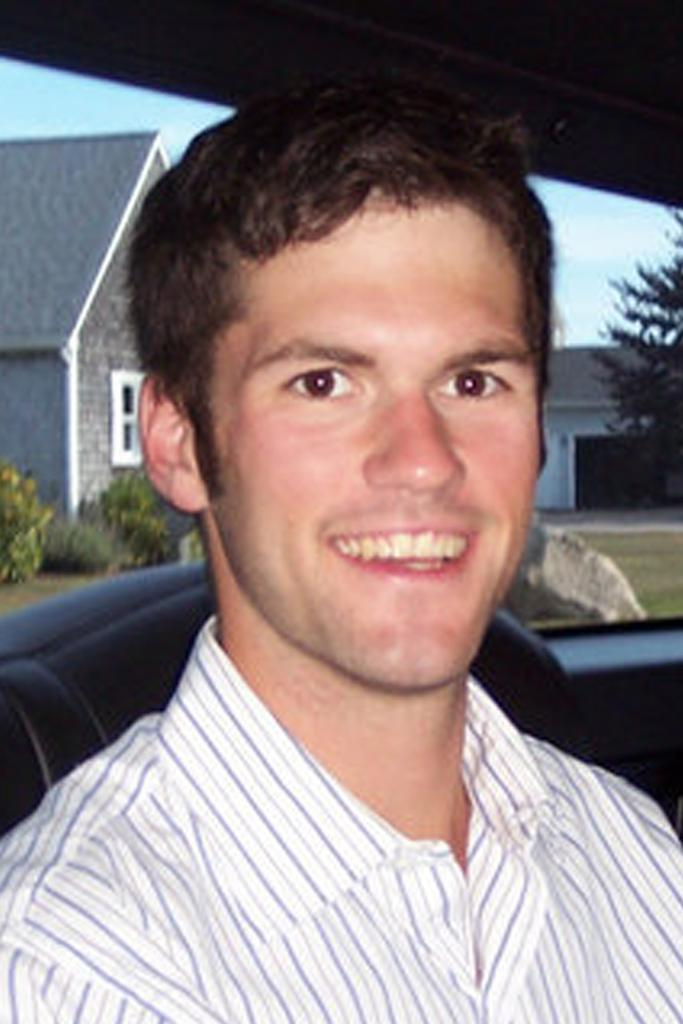What is the man in the image doing? The man is sitting in a vehicle. What is the man wearing in the image? The man is wearing a shirt. What is the man's emotional state in the image? The man is laughing. What can be seen in the background of the image? There is a house and bushes in the background of the image. What is the weather like in the image? The sky is sunny in the image. What type of skirt is the man wearing in the image? The man is not wearing a skirt in the image; he is wearing a shirt. Can you describe the downtown area visible in the image? There is no downtown area visible in the image; it features a man sitting in a vehicle with a sunny sky and a house and bushes in the background. 